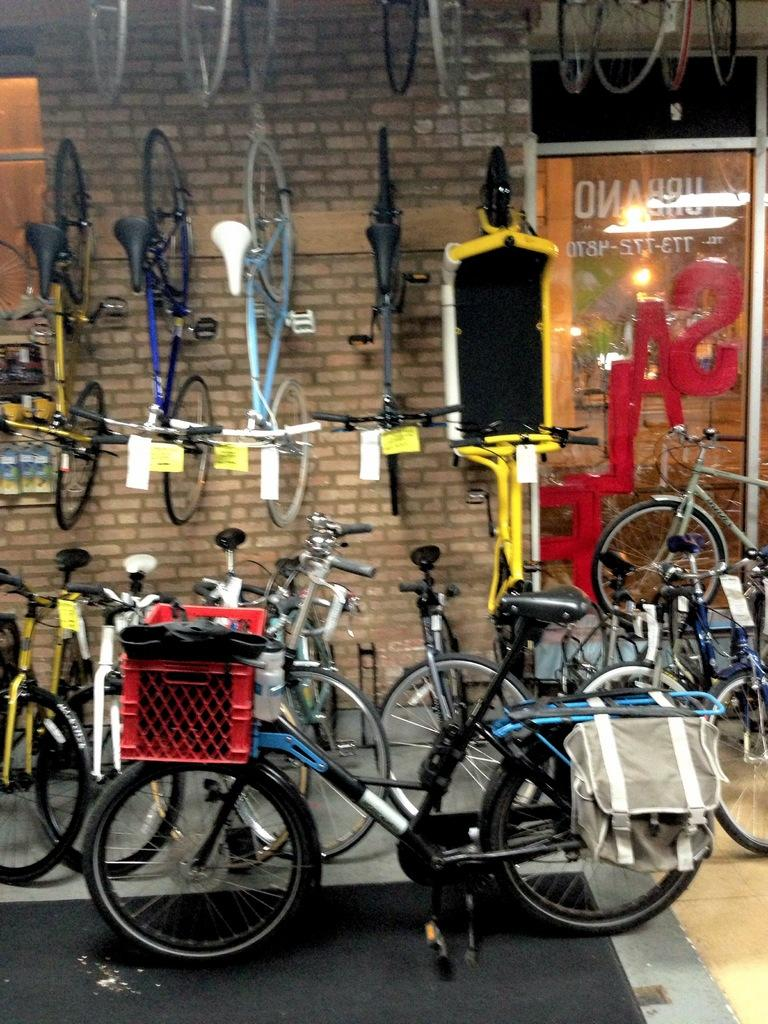What type of vehicles are present in the image? There are bicycles in the image. What object can be seen in the foreground of the image? There is a bag in the foreground of the image. What feature is present on one of the bicycles in the foreground? There is a basket on a bicycle in the foreground of the image. What can be seen in the background of the image? There is a board in the background of the image. What is happening to the board in the background of the image? There is a reflection of light on the board in the background of the image. What type of guitar is being played by the lettuce in the image? There is no guitar or lettuce present in the image. 